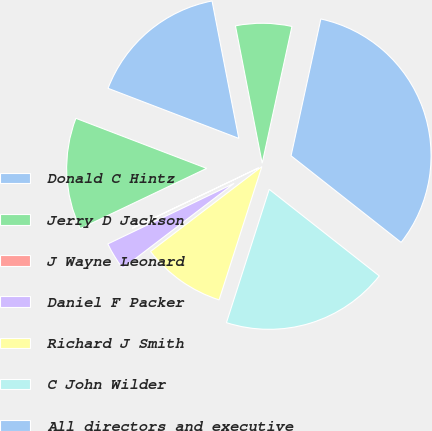Convert chart. <chart><loc_0><loc_0><loc_500><loc_500><pie_chart><fcel>Donald C Hintz<fcel>Jerry D Jackson<fcel>J Wayne Leonard<fcel>Daniel F Packer<fcel>Richard J Smith<fcel>C John Wilder<fcel>All directors and executive<fcel>Jerry W Yelverton<nl><fcel>16.12%<fcel>12.9%<fcel>0.04%<fcel>3.25%<fcel>9.69%<fcel>19.33%<fcel>32.2%<fcel>6.47%<nl></chart> 